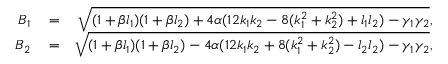Convert formula to latex. <formula><loc_0><loc_0><loc_500><loc_500>\begin{array} { r l r } { B _ { 1 } } & = } & { \sqrt { ( 1 + \beta l _ { 1 } ) ( 1 + \beta l _ { 2 } ) + 4 \alpha ( 1 2 k _ { 1 } k _ { 2 } - 8 ( k _ { 1 } ^ { 2 } + k _ { 2 } ^ { 2 } ) + l _ { 1 } l _ { 2 } ) - \gamma _ { 1 } \gamma _ { 2 } } , } \\ { B _ { 2 } } & = } & { \sqrt { ( 1 + \beta l _ { 1 } ) ( 1 + \beta l _ { 2 } ) - 4 \alpha ( 1 2 k _ { 1 } k _ { 2 } + 8 ( k _ { 1 } ^ { 2 } + k _ { 2 } ^ { 2 } ) - l _ { 2 } l _ { 2 } ) - \gamma _ { 1 } \gamma _ { 2 } } , } \end{array}</formula> 